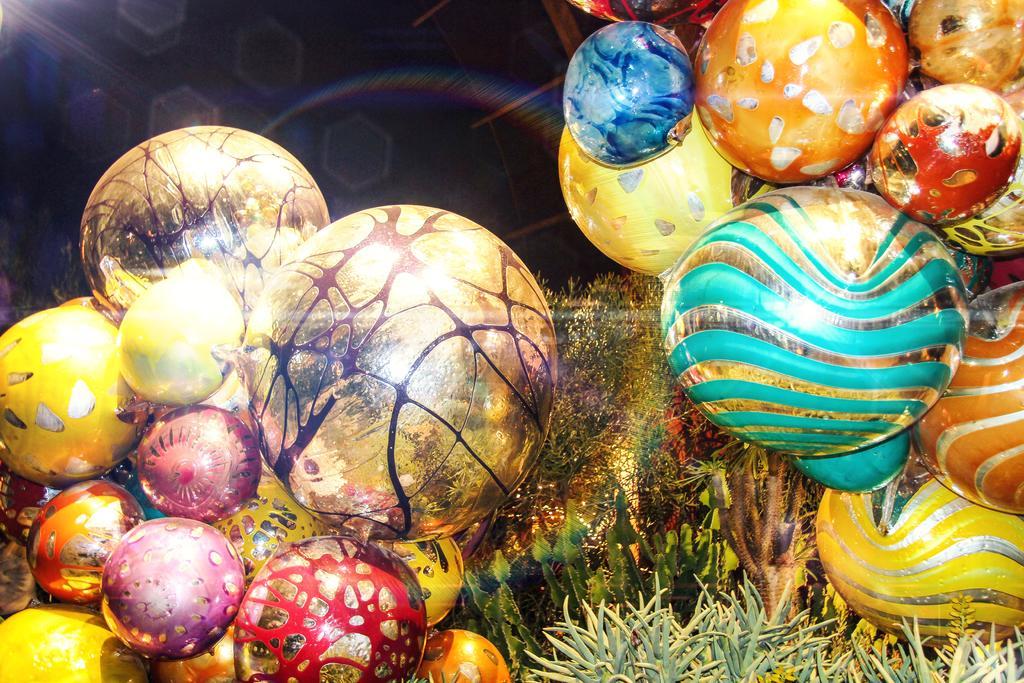Please provide a concise description of this image. In this image we can see circular shape decorative items, house plants in the foreground, in the background there is a light focus and dark view. 